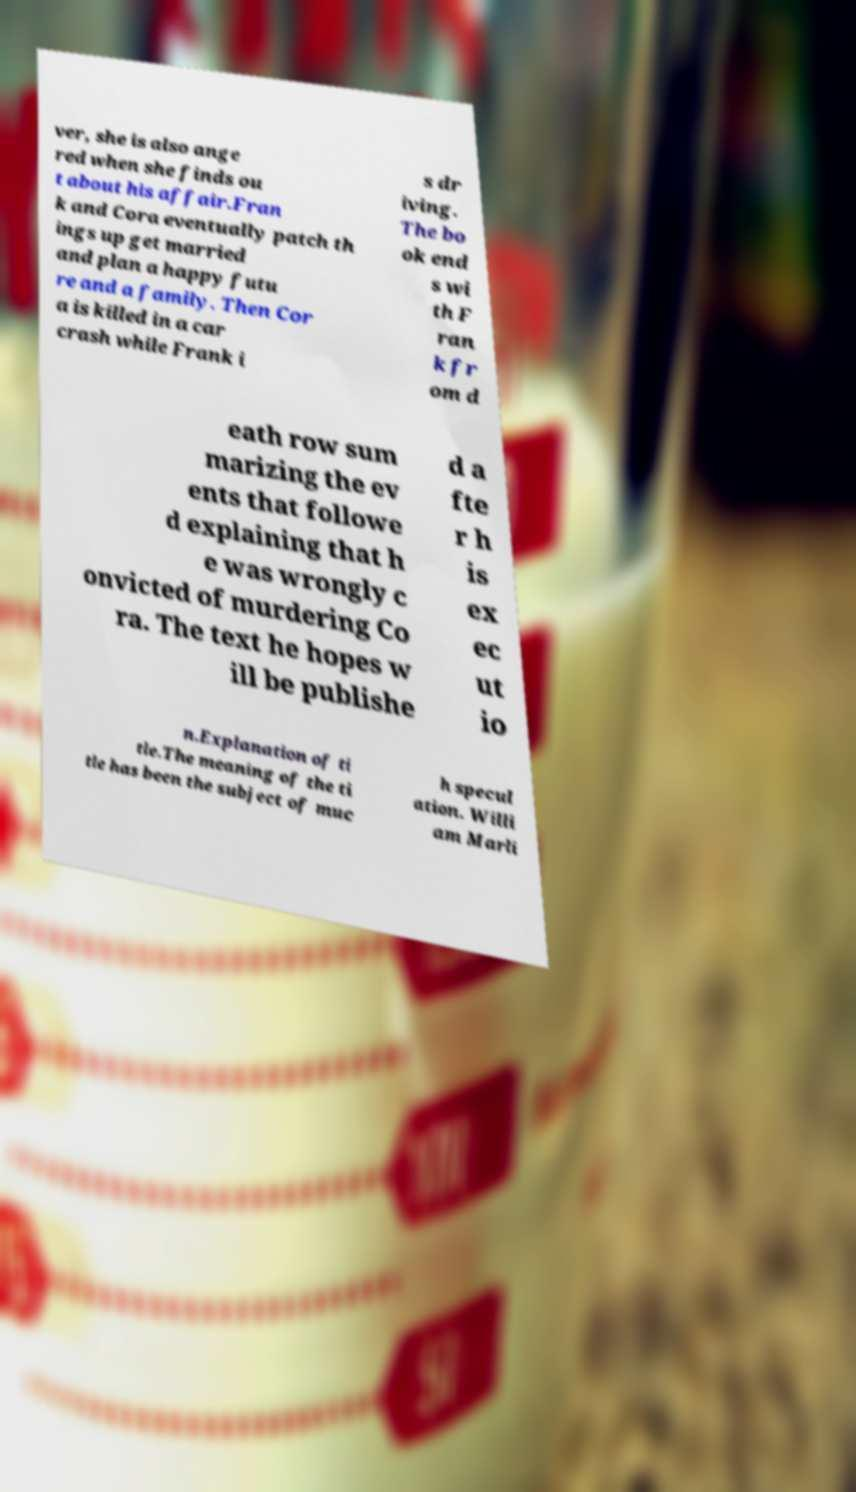Could you extract and type out the text from this image? ver, she is also ange red when she finds ou t about his affair.Fran k and Cora eventually patch th ings up get married and plan a happy futu re and a family. Then Cor a is killed in a car crash while Frank i s dr iving. The bo ok end s wi th F ran k fr om d eath row sum marizing the ev ents that followe d explaining that h e was wrongly c onvicted of murdering Co ra. The text he hopes w ill be publishe d a fte r h is ex ec ut io n.Explanation of ti tle.The meaning of the ti tle has been the subject of muc h specul ation. Willi am Marli 